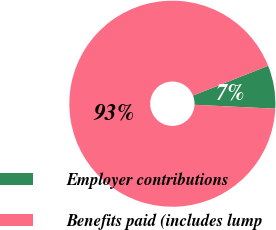<chart> <loc_0><loc_0><loc_500><loc_500><pie_chart><fcel>Employer contributions<fcel>Benefits paid (includes lump<nl><fcel>6.77%<fcel>93.23%<nl></chart> 